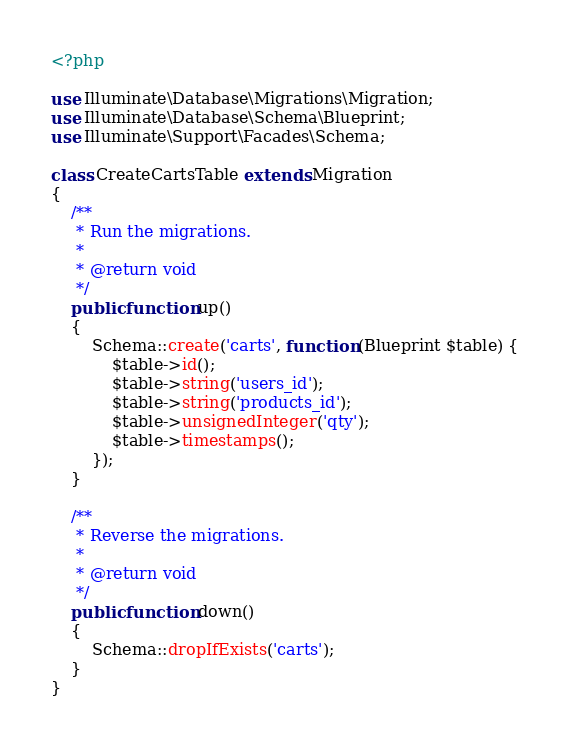Convert code to text. <code><loc_0><loc_0><loc_500><loc_500><_PHP_><?php

use Illuminate\Database\Migrations\Migration;
use Illuminate\Database\Schema\Blueprint;
use Illuminate\Support\Facades\Schema;

class CreateCartsTable extends Migration
{
    /**
     * Run the migrations.
     *
     * @return void
     */
    public function up()
    {
        Schema::create('carts', function (Blueprint $table) {
            $table->id();
            $table->string('users_id');
            $table->string('products_id');
            $table->unsignedInteger('qty');
            $table->timestamps();
        });
    }

    /**
     * Reverse the migrations.
     *
     * @return void
     */
    public function down()
    {
        Schema::dropIfExists('carts');
    }
}
</code> 